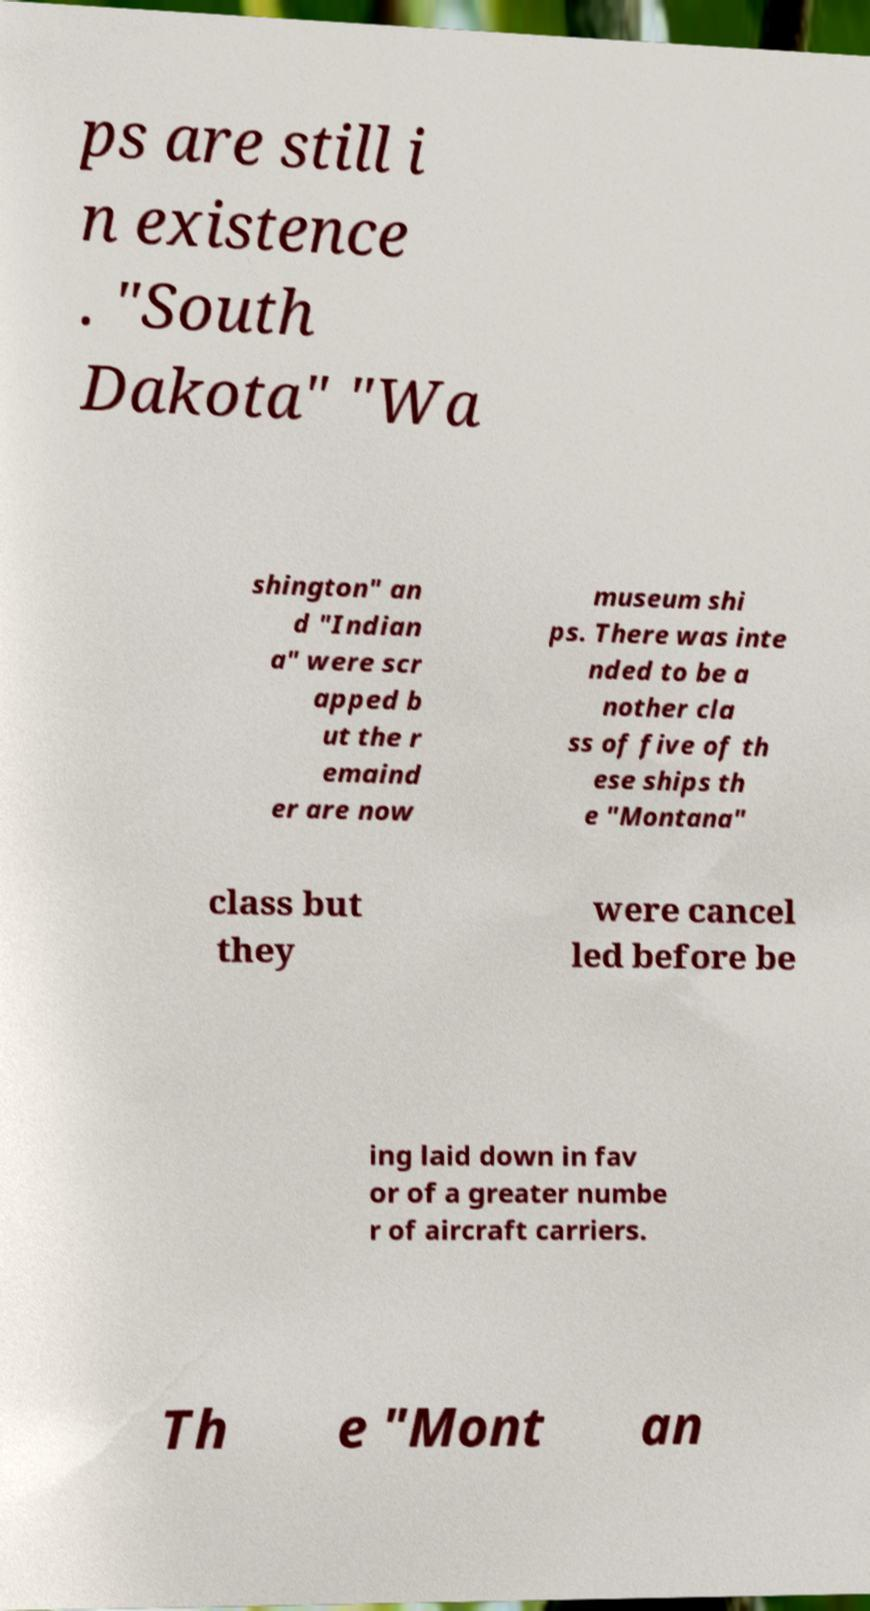Could you extract and type out the text from this image? ps are still i n existence . "South Dakota" "Wa shington" an d "Indian a" were scr apped b ut the r emaind er are now museum shi ps. There was inte nded to be a nother cla ss of five of th ese ships th e "Montana" class but they were cancel led before be ing laid down in fav or of a greater numbe r of aircraft carriers. Th e "Mont an 